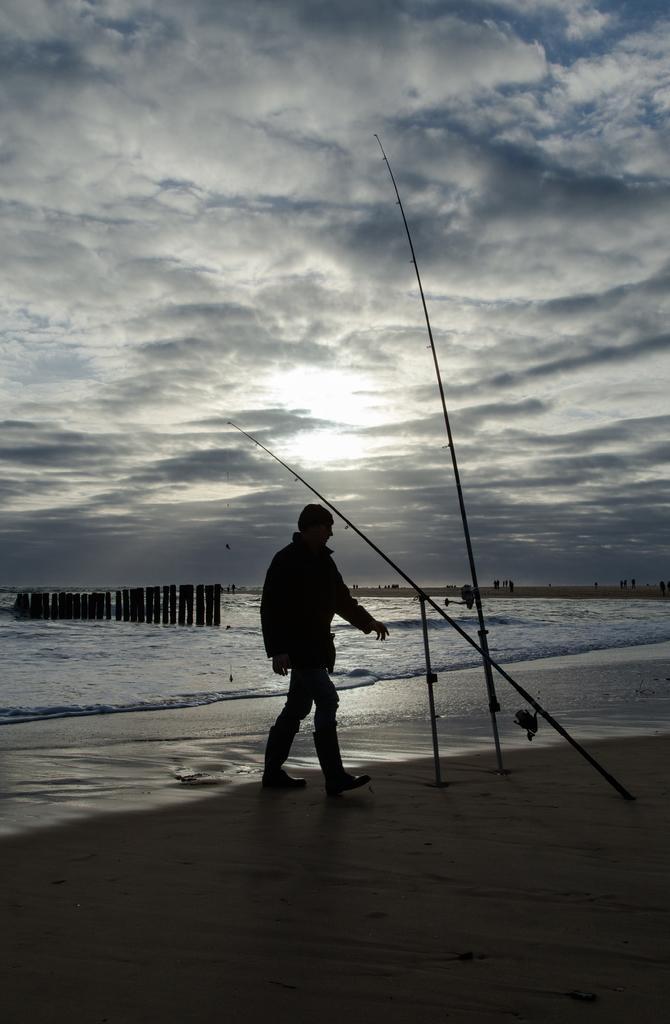Could you give a brief overview of what you see in this image? In the center of the image there is a person walking. At the bottom of the image there is sand. In the background of the image there is water. At the top of the image there are clouds. 